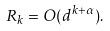<formula> <loc_0><loc_0><loc_500><loc_500>R _ { k } = O ( d ^ { k + \alpha } ) .</formula> 